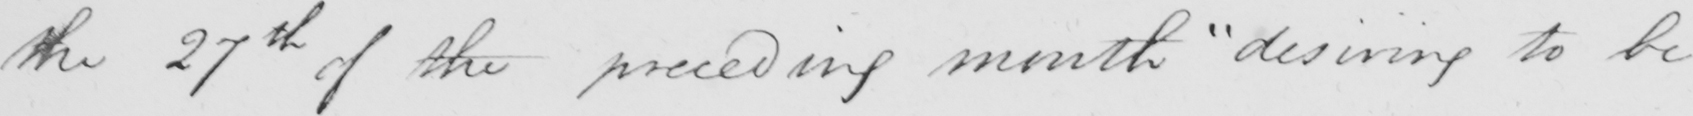Transcribe the text shown in this historical manuscript line. the 27th of the preceding month  " desiring to be 